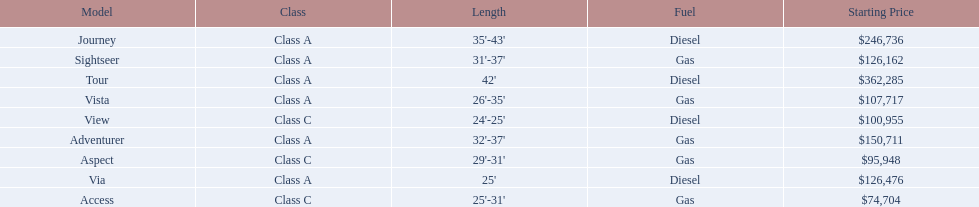What are all of the winnebago models? Tour, Journey, Adventurer, Via, Sightseer, Vista, View, Aspect, Access. What are their prices? $362,285, $246,736, $150,711, $126,476, $126,162, $107,717, $100,955, $95,948, $74,704. And which model costs the most? Tour. 